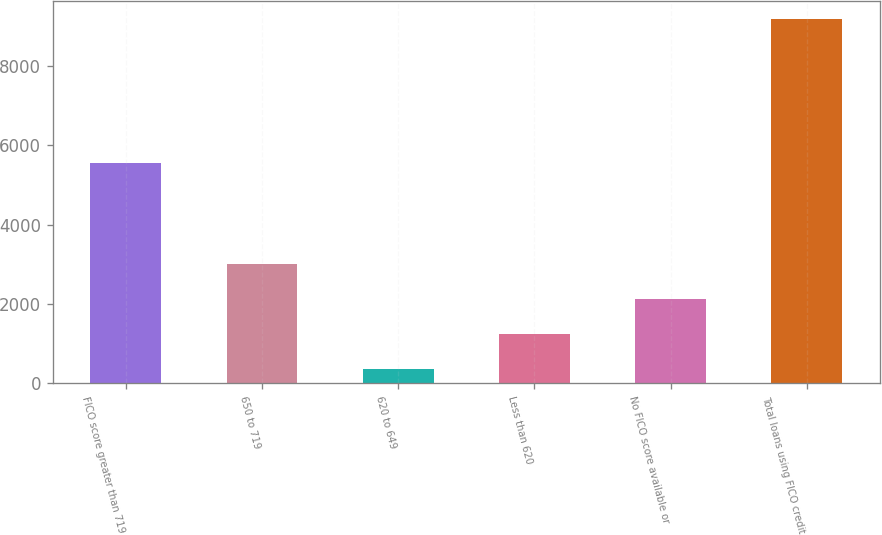Convert chart to OTSL. <chart><loc_0><loc_0><loc_500><loc_500><bar_chart><fcel>FICO score greater than 719<fcel>650 to 719<fcel>620 to 649<fcel>Less than 620<fcel>No FICO score available or<fcel>Total loans using FICO credit<nl><fcel>5556<fcel>3010.9<fcel>370<fcel>1250.3<fcel>2130.6<fcel>9173<nl></chart> 